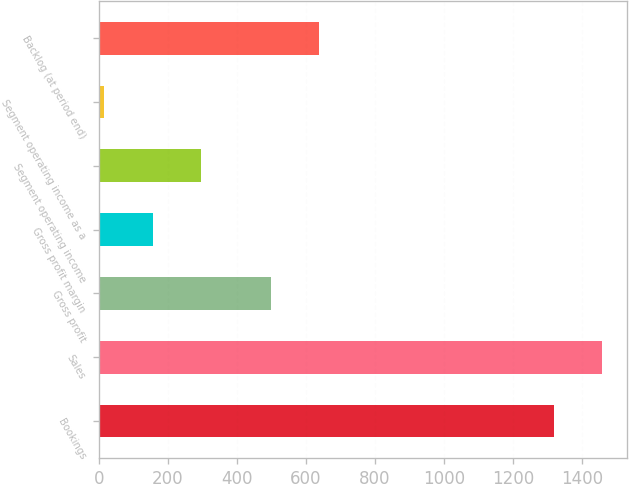Convert chart. <chart><loc_0><loc_0><loc_500><loc_500><bar_chart><fcel>Bookings<fcel>Sales<fcel>Gross profit<fcel>Gross profit margin<fcel>Segment operating income<fcel>Segment operating income as a<fcel>Backlog (at period end)<nl><fcel>1318.5<fcel>1458.39<fcel>497.5<fcel>156.49<fcel>296.38<fcel>16.6<fcel>637.39<nl></chart> 